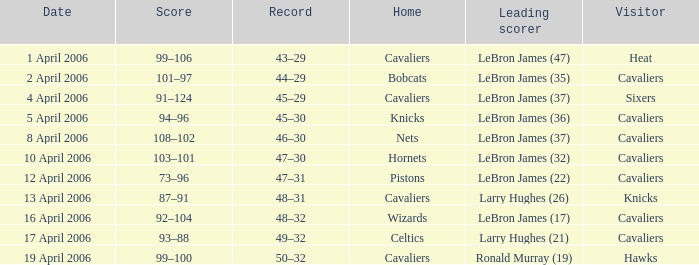What day was the game that had the Cavaliers as visiting team and the Knicks as the home team? 5 April 2006. 